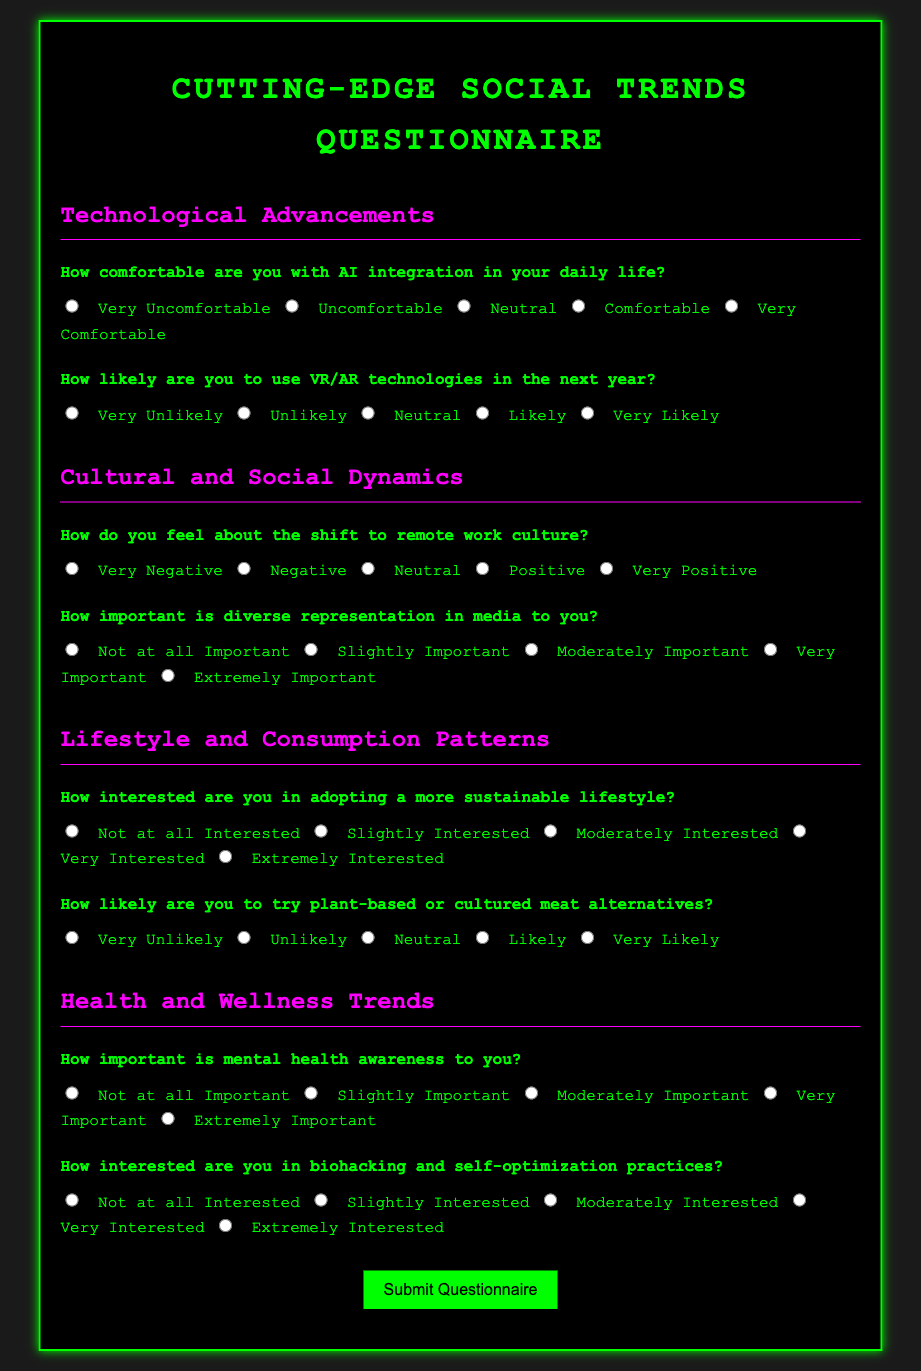What is the title of the document? The title of the document is located in the <title> tag and is the main identification of the document.
Answer: Cutting-Edge Social Trends Questionnaire How many sections are there in the questionnaire? The number of sections can be counted by looking at the headings that categorize the questions, each marked with a specific <h2> tag.
Answer: 4 What color is the background of the body? The background color can be identified in the CSS under the body style rule, which specifies the color value.
Answer: #1a1a1a How comfortable are you with AI integration in your daily life? This question is found in the first section about Technological Advancements, and it assesses personal feelings towards AI.
Answer: Short answer expected from respondent What is the highest importance rating available for diverse representation in media? The highest rating is defined in the questionnaire options for that specific question, indicating the degree of importance.
Answer: Extremely Important Which section addresses health and wellness trends? The section can be identified by its heading <h2> that specifically mentions health and wellness, grouping relevant questions together.
Answer: Health and Wellness Trends How likely are you to try plant-based or cultured meat alternatives? This is a direct query from the Lifestyle and Consumption Patterns section and requires a personal stance from the respondent.
Answer: Short answer expected from respondent How important is mental health awareness to you? This question is framed to evaluate the priority given to mental health awareness by the respondent and is found in the Health and Wellness Trends section.
Answer: Short answer expected from respondent What color is the submit button when hovered over? The hover state of the submit button is specified in the CSS, describing the visual change when interacted with.
Answer: #ff00ff 